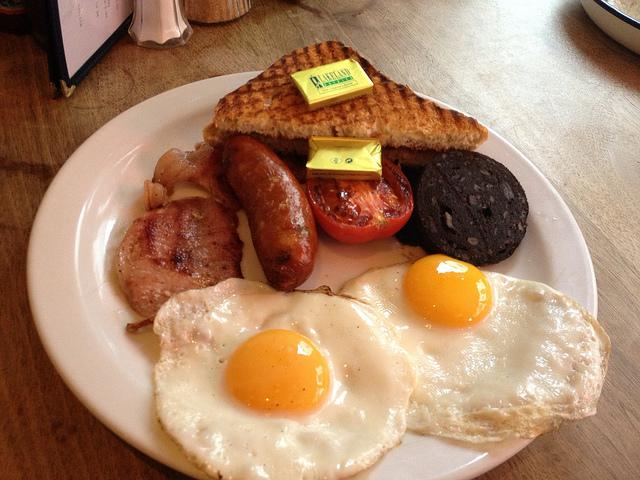How many eggs are served in this breakfast overeasy?

Choices:
A) four
B) three
C) two
D) five two 